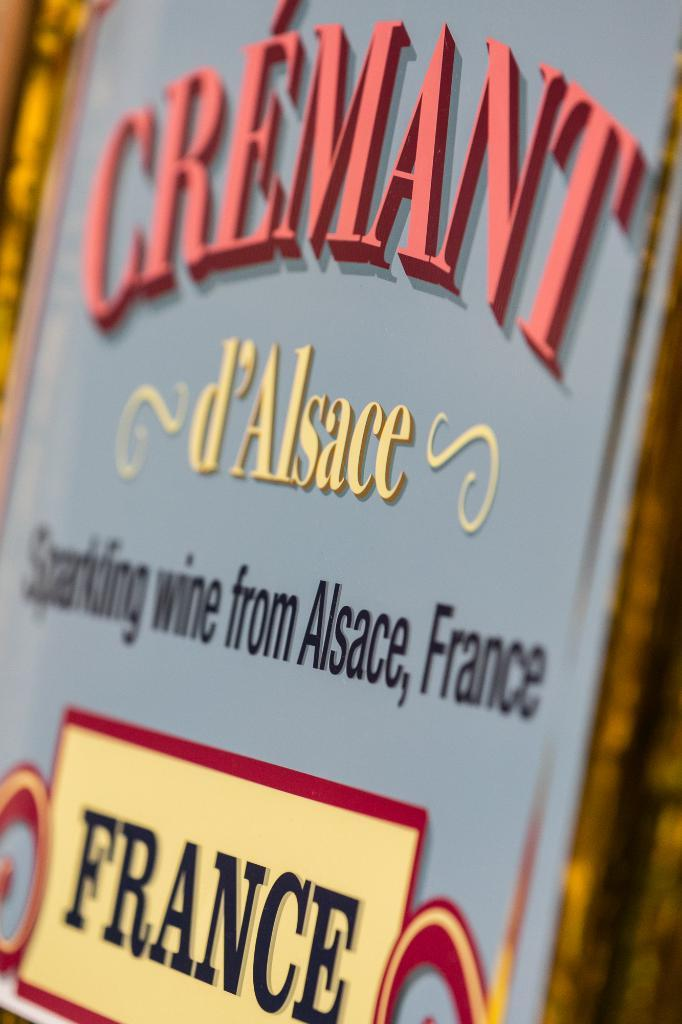Provide a one-sentence caption for the provided image. A decorative sign for sparkling wine from France. 